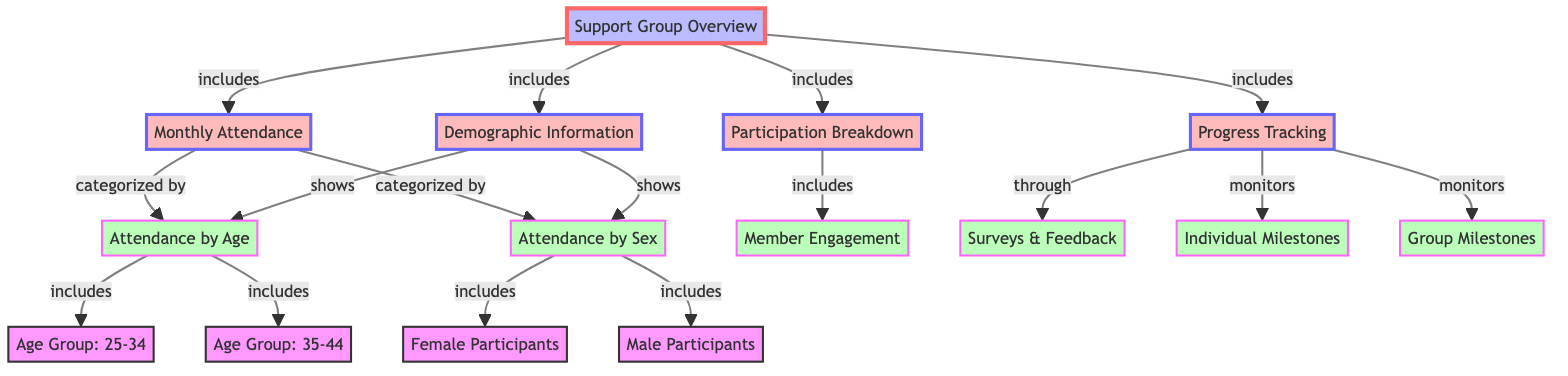What categories are included in Monthly Attendance? The diagram shows that Monthly Attendance is categorized by Attendance by Age and Attendance by Sex. These categories help break down the attendance data into specific demographics.
Answer: Attendance by Age, Attendance by Sex How many major sections are indicated in the Support Group Overview? The Support Group Overview has four major sections that include Monthly Attendance, Participation Breakdown, Demographic Information, and Progress Tracking. Each section provides different insights related to the support group.
Answer: 4 What demographic groups are identified under Attendance by Sex? The diagram indicates that Attendance by Sex includes Female Participants and Male Participants, allowing us to see a breakdown based on gender.
Answer: Female Participants, Male Participants What two types of milestones are monitored in Progress Tracking? Progress Tracking is shown to monitor Individual Milestones and Group Milestones, indicating that both personal and collective achievements are tracked within the support group framework.
Answer: Individual Milestones, Group Milestones How does Participation Breakdown relate to Member Engagement? According to the diagram, Participation Breakdown includes Member Engagement as a part of understanding the overall participation metrics within the support group. This shows that engagement is key in assessing participation.
Answer: Includes What does the diagram indicate about the relationship between Monthly Attendance and Demographic Information? The diagram indicates that both Monthly Attendance and Demographic Information are key components of the Support Group Overview, showing that understanding attendance is linked with understanding demographics.
Answer: Both are included What age groups are represented under Attendance by Age? Under Attendance by Age, the diagram specifically lists Age Group: 25-34 and Age Group: 35-44, thereby indicating these are the focused age demographics for tracking attendance.
Answer: Age Group: 25-34, Age Group: 35-44 How does the diagram facilitate feedback collection? The diagram illustrates that Progress Tracking includes Surveys & Feedback, which serves as a method for gathering insights and opinions from participants to improve the support group experience.
Answer: Surveys & Feedback What is the primary function of the Support Group Overview? The primary function of the Support Group Overview is to provide a comprehensive view of attendance, participation, demographics, and progress, thereby serving as an overall management tool for the support group.
Answer: Comprehensive view 